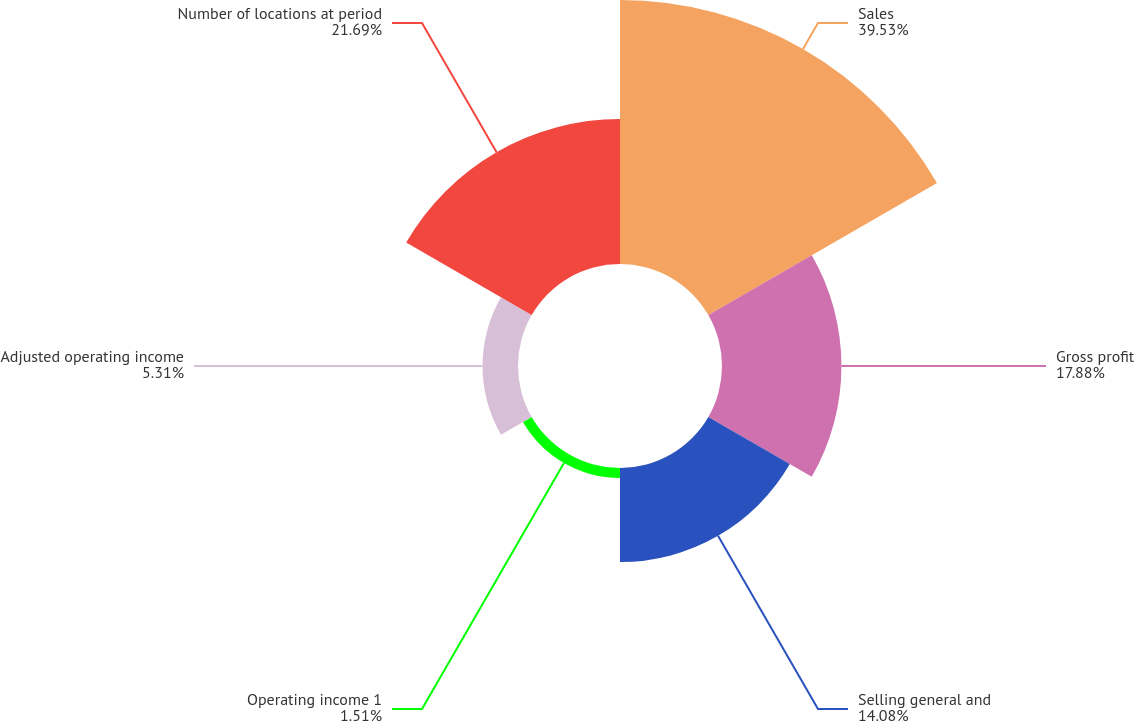Convert chart to OTSL. <chart><loc_0><loc_0><loc_500><loc_500><pie_chart><fcel>Sales<fcel>Gross profit<fcel>Selling general and<fcel>Operating income 1<fcel>Adjusted operating income<fcel>Number of locations at period<nl><fcel>39.52%<fcel>17.88%<fcel>14.08%<fcel>1.51%<fcel>5.31%<fcel>21.69%<nl></chart> 